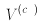Convert formula to latex. <formula><loc_0><loc_0><loc_500><loc_500>V ^ { ( c _ { n } ) }</formula> 